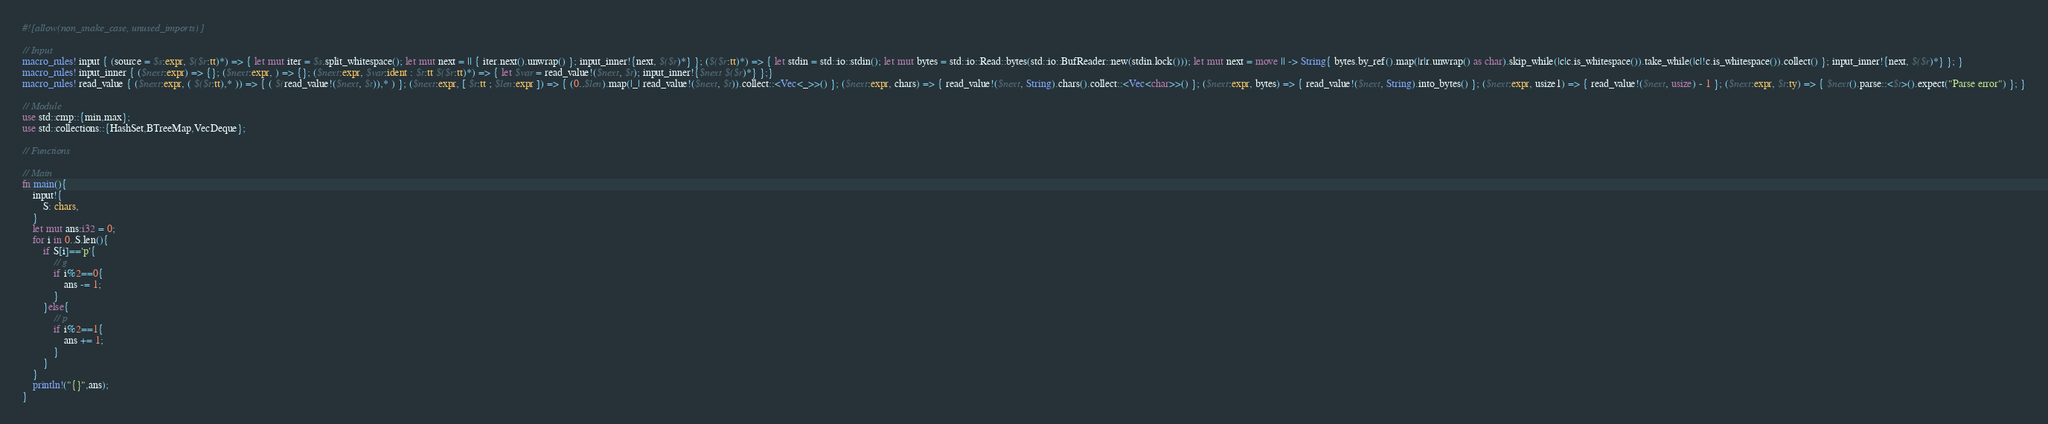Convert code to text. <code><loc_0><loc_0><loc_500><loc_500><_Rust_>#![allow(non_snake_case, unused_imports)]

// Input
macro_rules! input { (source = $s:expr, $($r:tt)*) => { let mut iter = $s.split_whitespace(); let mut next = || { iter.next().unwrap() }; input_inner!{next, $($r)*} }; ($($r:tt)*) => { let stdin = std::io::stdin(); let mut bytes = std::io::Read::bytes(std::io::BufReader::new(stdin.lock())); let mut next = move || -> String{ bytes.by_ref().map(|r|r.unwrap() as char).skip_while(|c|c.is_whitespace()).take_while(|c|!c.is_whitespace()).collect() }; input_inner!{next, $($r)*} }; }
macro_rules! input_inner { ($next:expr) => {}; ($next:expr, ) => {}; ($next:expr, $var:ident : $t:tt $($r:tt)*) => { let $var = read_value!($next, $t); input_inner!{$next $($r)*} };}
macro_rules! read_value { ($next:expr, ( $($t:tt),* )) => { ( $(read_value!($next, $t)),* ) }; ($next:expr, [ $t:tt ; $len:expr ]) => { (0..$len).map(|_| read_value!($next, $t)).collect::<Vec<_>>() }; ($next:expr, chars) => { read_value!($next, String).chars().collect::<Vec<char>>() }; ($next:expr, bytes) => { read_value!($next, String).into_bytes() }; ($next:expr, usize1) => { read_value!($next, usize) - 1 }; ($next:expr, $t:ty) => { $next().parse::<$t>().expect("Parse error") }; }

// Module
use std::cmp::{min,max};
use std::collections::{HashSet,BTreeMap,VecDeque};

// Functions

// Main
fn main(){
    input!{
        S: chars,
    }
    let mut ans:i32 = 0;
    for i in 0..S.len(){
        if S[i]=='p'{
            // g
            if i%2==0{
                ans -= 1;
            }
        }else{
            // p
            if i%2==1{
                ans += 1;
            }
        }
    }
    println!("{}",ans);
}</code> 